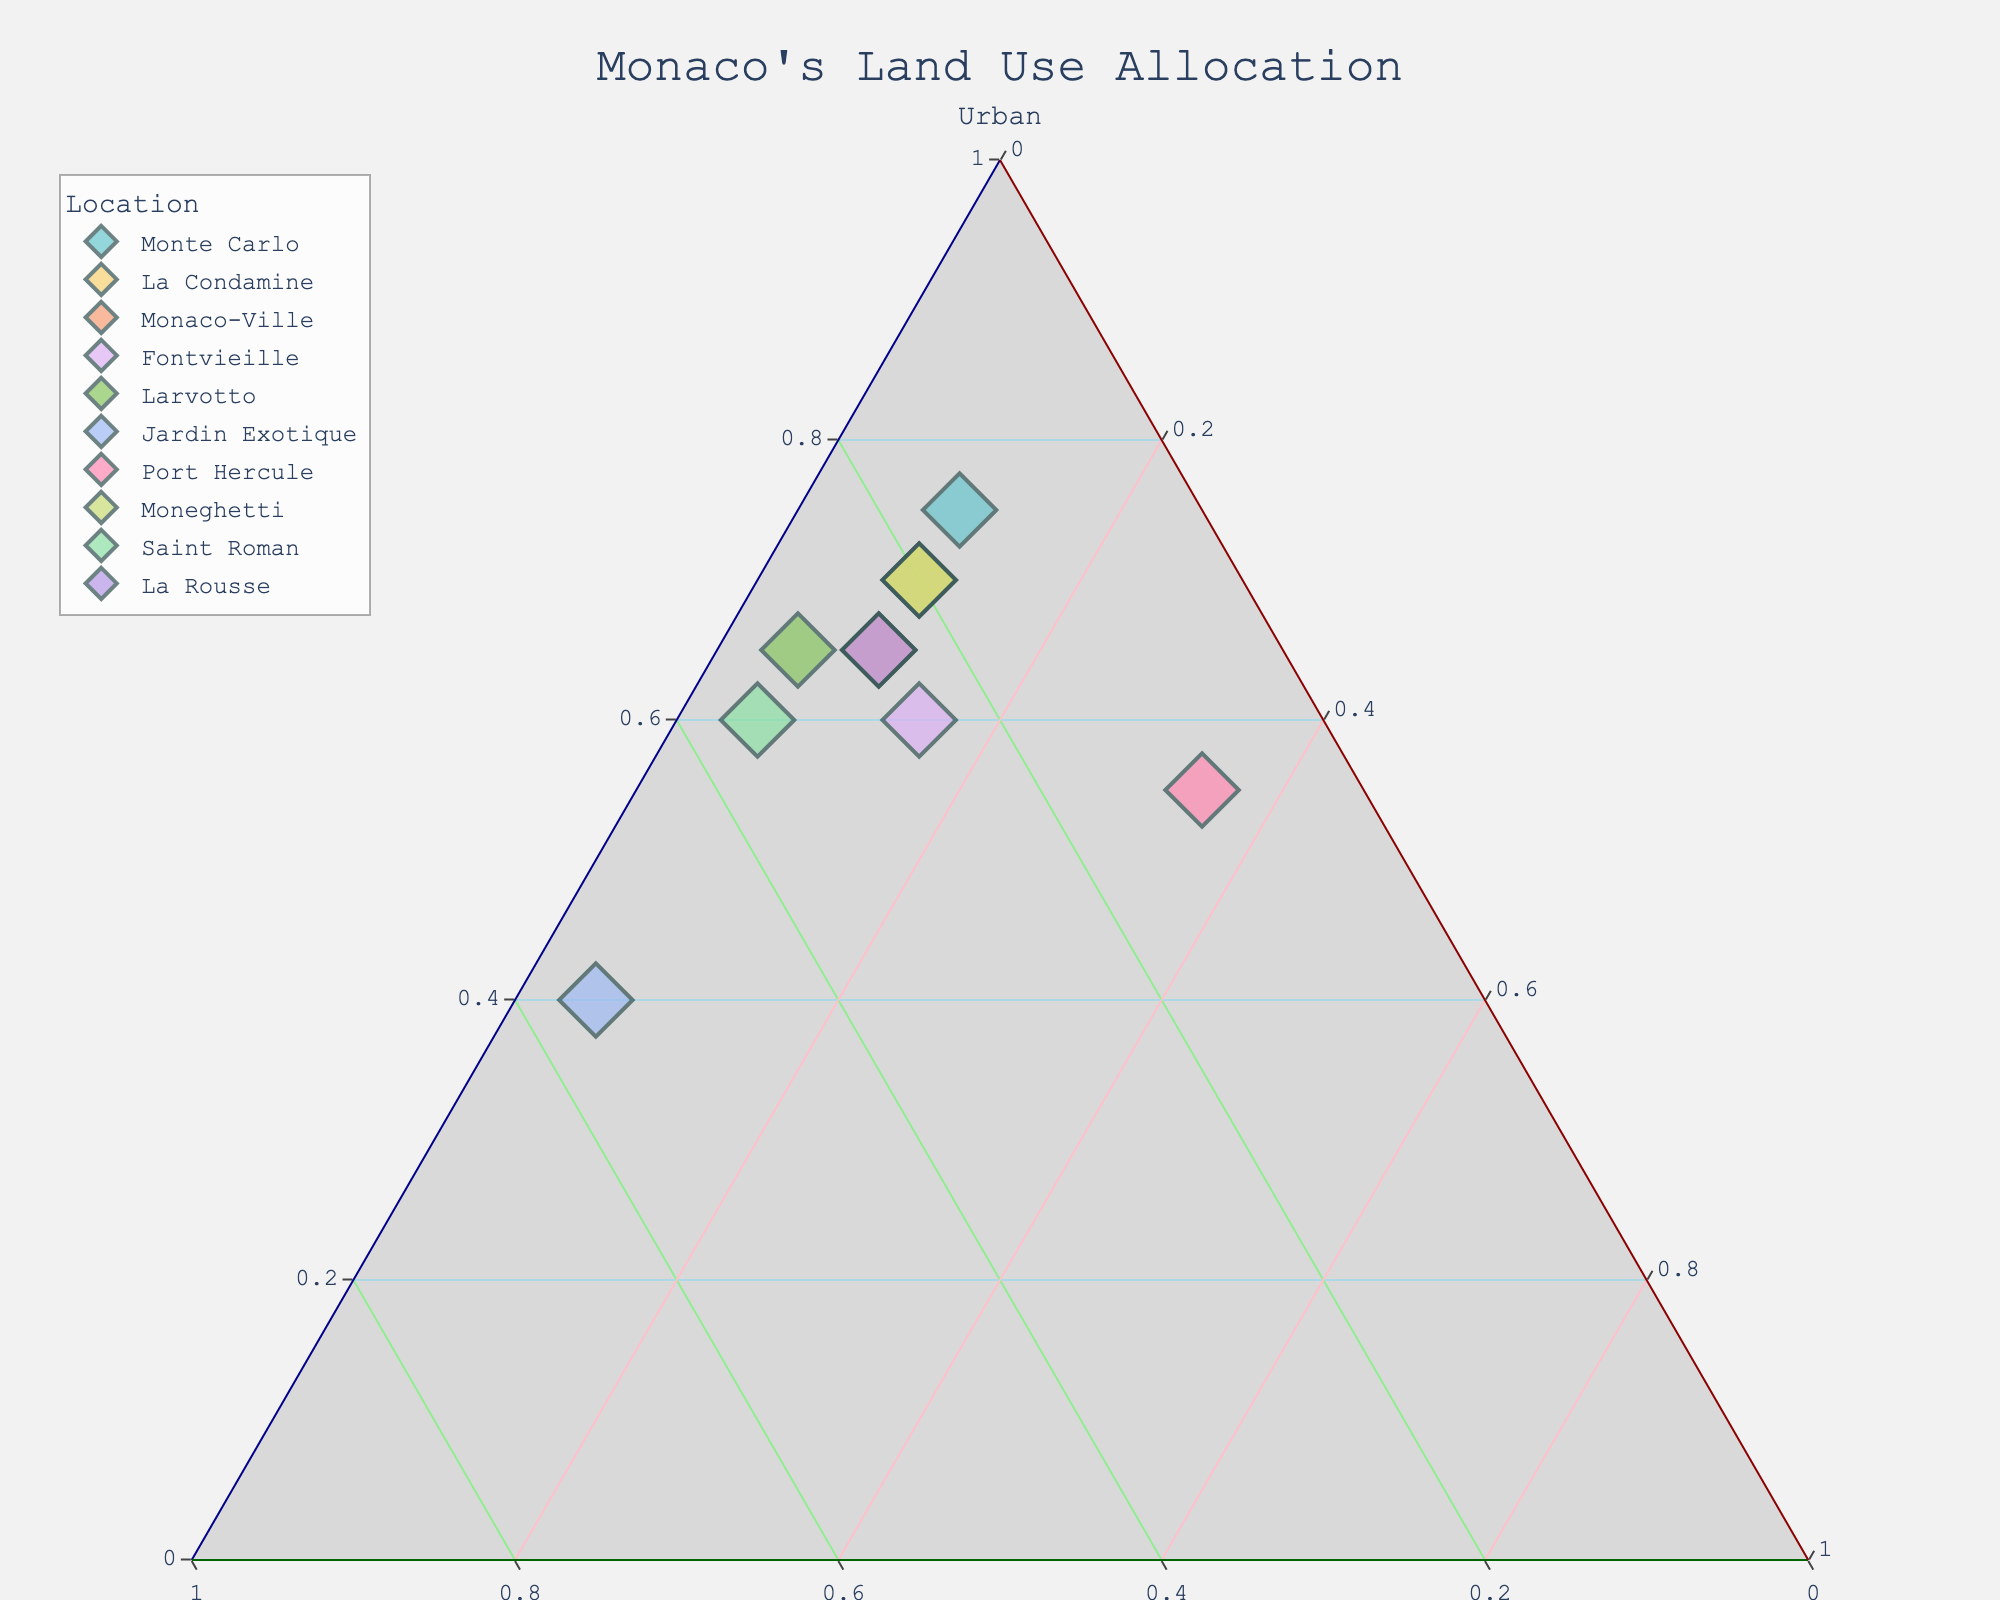What is the title of the plot? The title of the plot is usually located at the top center of the figure. By looking at this area, we can identify the title.
Answer: Monaco's Land Use Allocation How many locations are represented in the plot? By counting the number of unique data points or markers on the plot, we can determine the number of locations represented.
Answer: 10 Which location has the highest percentage of green spaces? The data points closest to the "Green spaces" corner (top corner) represent locations with the highest percentages of green spaces. Jardin Exotique should be closest to this corner as it has the highest value in the data.
Answer: Jardin Exotique Compare the proportion of infrastructure between La Condamine and Fontvieille. Which one is higher? To compare the proportions, look at the distances of these locations from the "Infrastructure" corner (bottom corner). The data point further away has a lower percentage. Fontvieille has a higher percentage as it is closer to the Infrastructure corner.
Answer: Fontvieille What is the median percentage of urban allocation across all locations? First, list the urban percentage values for all locations. Then, order these values and identify the middle value(s). If there's an even number of data points, calculate the average of the two middle values. Urban percentages: 40, 55, 60, 60, 65, 65, 65, 70, 70, 75. The median is the average of the 5th and 6th values: (65 + 65) / 2.
Answer: 65% Which location has the most balanced allocation among urban, green spaces, and infrastructure? A balanced allocation implies that the data point is equidistant from all three corners. This will likely be near the center of the plot. By observing the plotted points, Monaco-Ville and Moneghetti seem fairly balanced, but Monaco-Ville is more balanced.
Answer: Monaco-Ville What is the difference in urban allocation between Monte Carlo and Saint Roman? Subtract the percentage of urban allocation for Saint Roman from that of Monte Carlo. Monte Carlo: 75%, Saint Roman: 60%. The difference is 75% - 60%.
Answer: 15% Which two locations have the same proportion of infrastructure? Look for locations that share the same distance from the "Infrastructure" corner. Both Monte Carlo and La Condamine have the same percentages for infrastructure.
Answer: Monte Carlo and La Condamine What is the average percentage of green spaces across all locations? Add the green spaces percentages for all locations and divide by the number of locations. (15 + 20 + 25 + 25 + 30 + 55 + 10 + 20 + 35 + 25) / 10.
Answer: 26% Which location has the lowest percentage of urban allocation? The data point closest to the "Green spaces" and "Infrastructure" corners, which would be Jardin Exotique as it has only 40% urban allocation in the data.
Answer: Jardin Exotique 